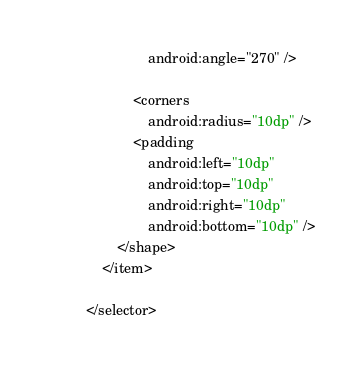<code> <loc_0><loc_0><loc_500><loc_500><_XML_>                android:angle="270" />

            <corners
                android:radius="10dp" />
            <padding
                android:left="10dp"
                android:top="10dp"
                android:right="10dp"
                android:bottom="10dp" />
        </shape>
    </item>

</selector></code> 